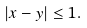<formula> <loc_0><loc_0><loc_500><loc_500>| x - y | \leq 1 .</formula> 